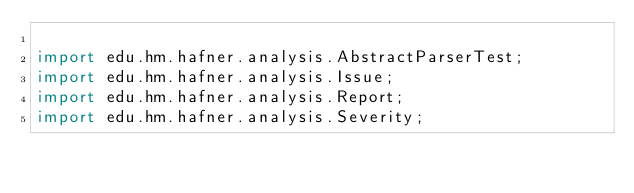Convert code to text. <code><loc_0><loc_0><loc_500><loc_500><_Java_>
import edu.hm.hafner.analysis.AbstractParserTest;
import edu.hm.hafner.analysis.Issue;
import edu.hm.hafner.analysis.Report;
import edu.hm.hafner.analysis.Severity;</code> 